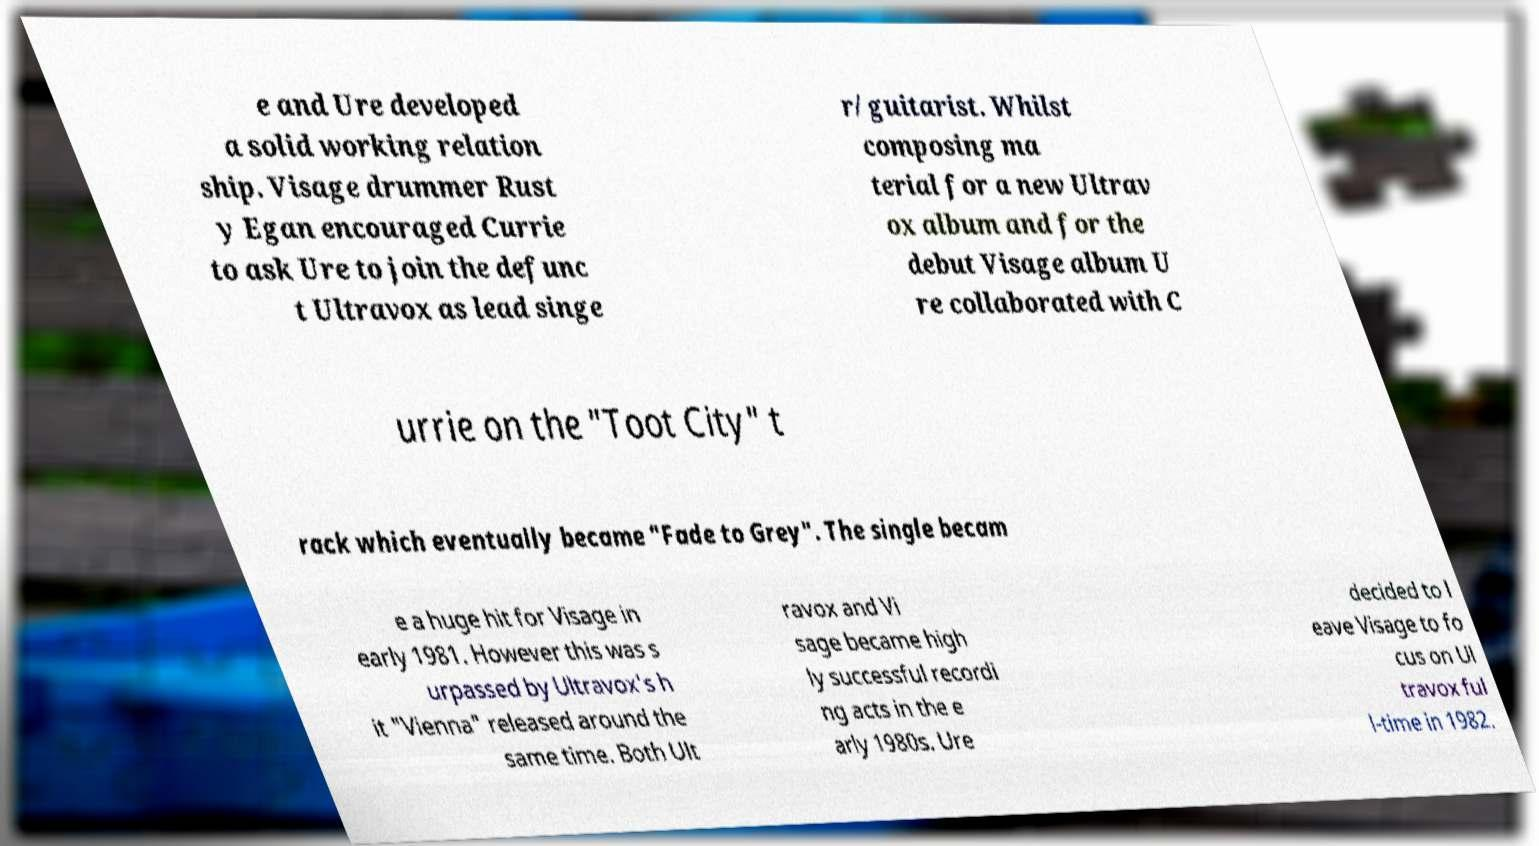Please identify and transcribe the text found in this image. e and Ure developed a solid working relation ship. Visage drummer Rust y Egan encouraged Currie to ask Ure to join the defunc t Ultravox as lead singe r/guitarist. Whilst composing ma terial for a new Ultrav ox album and for the debut Visage album U re collaborated with C urrie on the "Toot City" t rack which eventually became "Fade to Grey". The single becam e a huge hit for Visage in early 1981. However this was s urpassed by Ultravox's h it "Vienna" released around the same time. Both Ult ravox and Vi sage became high ly successful recordi ng acts in the e arly 1980s. Ure decided to l eave Visage to fo cus on Ul travox ful l-time in 1982. 